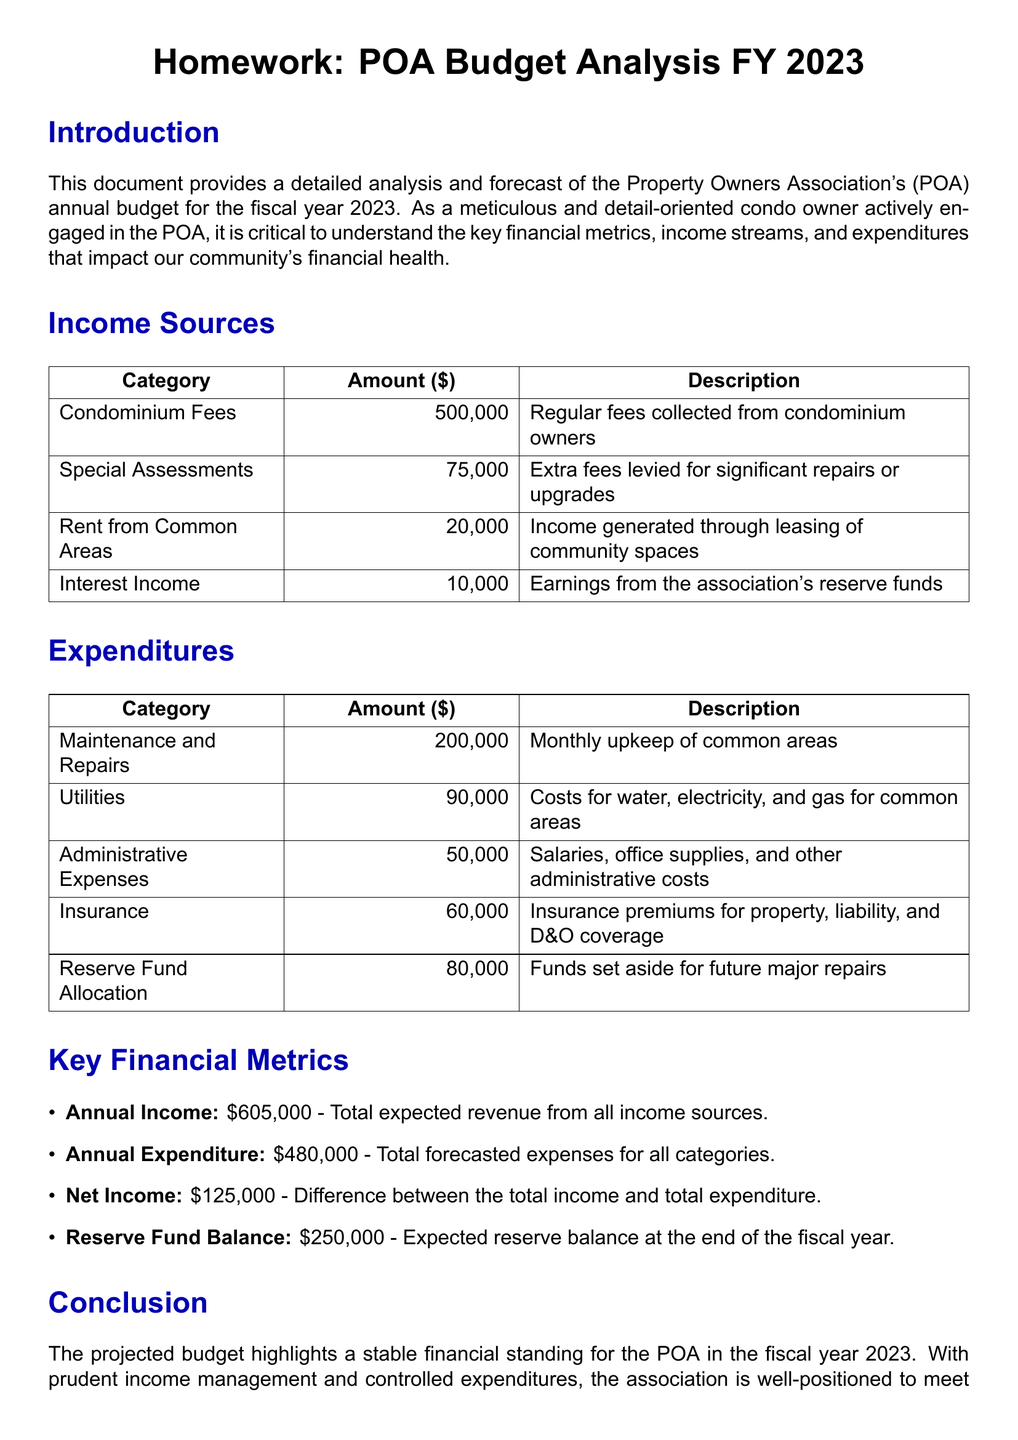What is the total income from condominium fees? The total income from condominium fees is specified in the income sources table under the category "Condominium Fees".
Answer: 500,000 What is the total amount allocated for maintenance and repairs? The total amount for maintenance and repairs is detailed in the expenditures table under the category "Maintenance and Repairs".
Answer: 200,000 What is the annual net income? The annual net income is calculated as the difference between the total income and total expenditure, stated in the key financial metrics section.
Answer: 125,000 How much is the expected reserve fund balance at the end of the fiscal year? The expected reserve fund balance is found in the key financial metrics section as the "Reserve Fund Balance".
Answer: 250,000 What are the administrative expenses? The administrative expenses are listed in the expenditures table under the category "Administrative Expenses".
Answer: 50,000 What is the total forecasted expenditure? The total forecasted expenditure is reported in the key financial metrics section.
Answer: 480,000 How much income is generated from renting common areas? Income from renting common areas is specified in the income sources table under the category "Rent from Common Areas".
Answer: 20,000 What is the total special assessments amount? The total special assessments amount is provided in the income sources table under the category "Special Assessments".
Answer: 75,000 What are utility costs for the POA? Utility costs are specified in the expenditures table under the category "Utilities".
Answer: 90,000 How much is allocated to the reserve fund? The amount allocated to the reserve fund is stated in the expenditures table under the category "Reserve Fund Allocation".
Answer: 80,000 